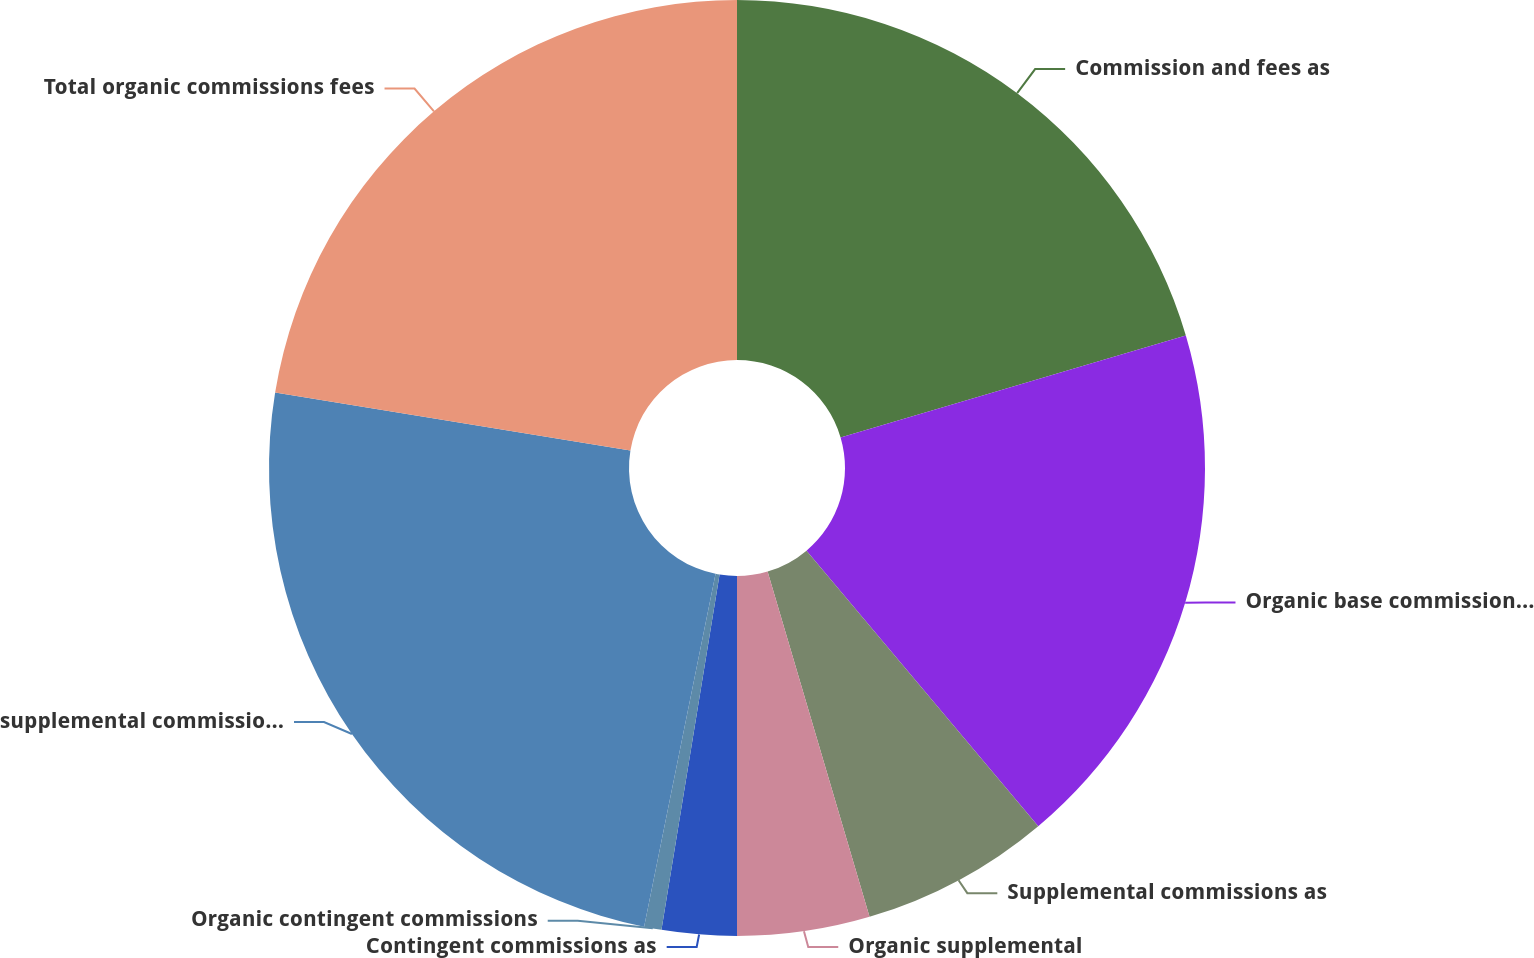<chart> <loc_0><loc_0><loc_500><loc_500><pie_chart><fcel>Commission and fees as<fcel>Organic base commission and<fcel>Supplemental commissions as<fcel>Organic supplemental<fcel>Contingent commissions as<fcel>Organic contingent commissions<fcel>supplemental commissions and<fcel>Total organic commissions fees<nl><fcel>20.43%<fcel>18.44%<fcel>6.56%<fcel>4.57%<fcel>2.58%<fcel>0.6%<fcel>24.4%<fcel>22.42%<nl></chart> 